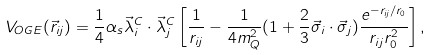Convert formula to latex. <formula><loc_0><loc_0><loc_500><loc_500>V _ { O G E } ( \vec { r } _ { i j } ) = \frac { 1 } { 4 } \alpha _ { s } \vec { \lambda } _ { i } ^ { C } \cdot \vec { \lambda } _ { j } ^ { C } \left [ \frac { 1 } { r _ { i j } } - \frac { 1 } { 4 m _ { Q } ^ { 2 } } ( 1 + \frac { 2 } { 3 } \vec { \sigma } _ { i } \cdot \vec { \sigma } _ { j } ) \frac { e ^ { - r _ { i j } / r _ { 0 } } } { r _ { i j } r _ { 0 } ^ { 2 } } \right ] ,</formula> 